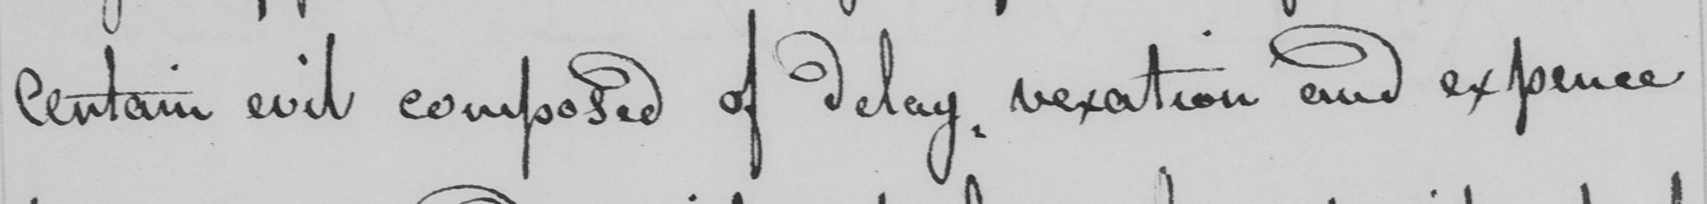Please transcribe the handwritten text in this image. certain evil composed of delay, vexation and expence 